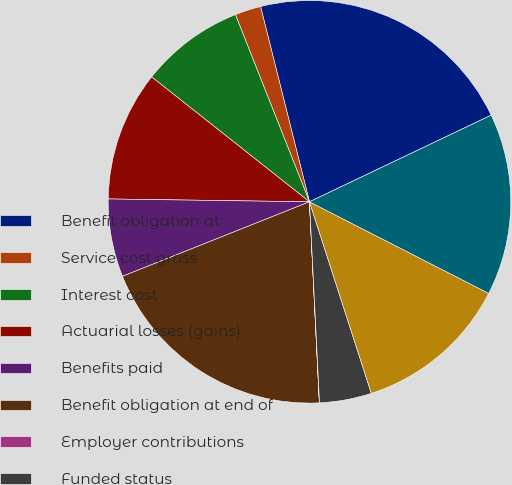Convert chart to OTSL. <chart><loc_0><loc_0><loc_500><loc_500><pie_chart><fcel>Benefit obligation at<fcel>Service cost gross<fcel>Interest cost<fcel>Actuarial losses (gains)<fcel>Benefits paid<fcel>Benefit obligation at end of<fcel>Employer contributions<fcel>Funded status<fcel>Net actuarial loss (gain)<fcel>Net amount recognized<nl><fcel>21.83%<fcel>2.09%<fcel>8.35%<fcel>10.43%<fcel>6.26%<fcel>19.75%<fcel>0.01%<fcel>4.18%<fcel>12.51%<fcel>14.6%<nl></chart> 